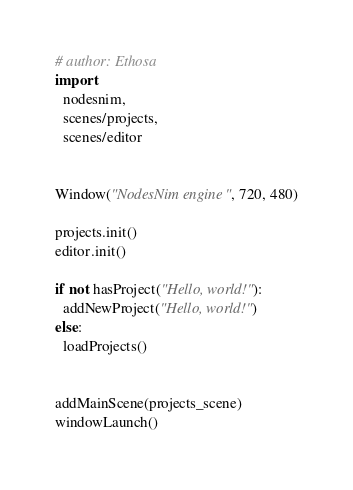Convert code to text. <code><loc_0><loc_0><loc_500><loc_500><_Nim_># author: Ethosa
import
  nodesnim,
  scenes/projects,
  scenes/editor


Window("NodesNim engine", 720, 480)

projects.init()
editor.init()

if not hasProject("Hello, world!"):
  addNewProject("Hello, world!")
else:
  loadProjects()


addMainScene(projects_scene)
windowLaunch()
</code> 